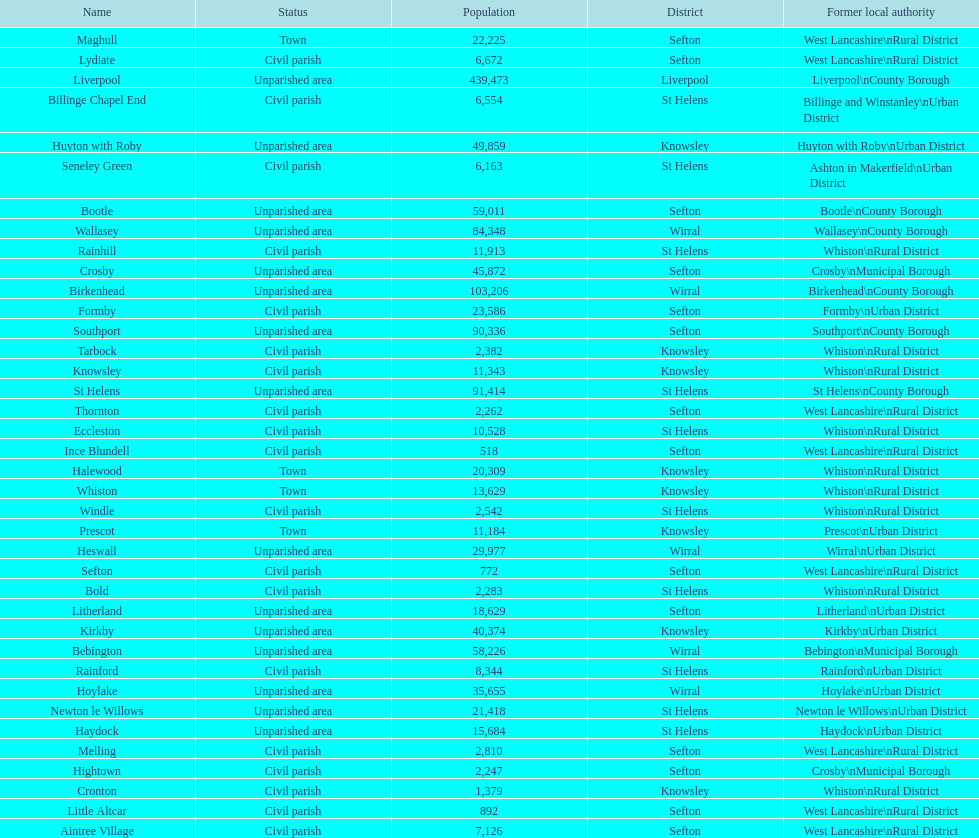Tell me the number of residents in formby. 23,586. 